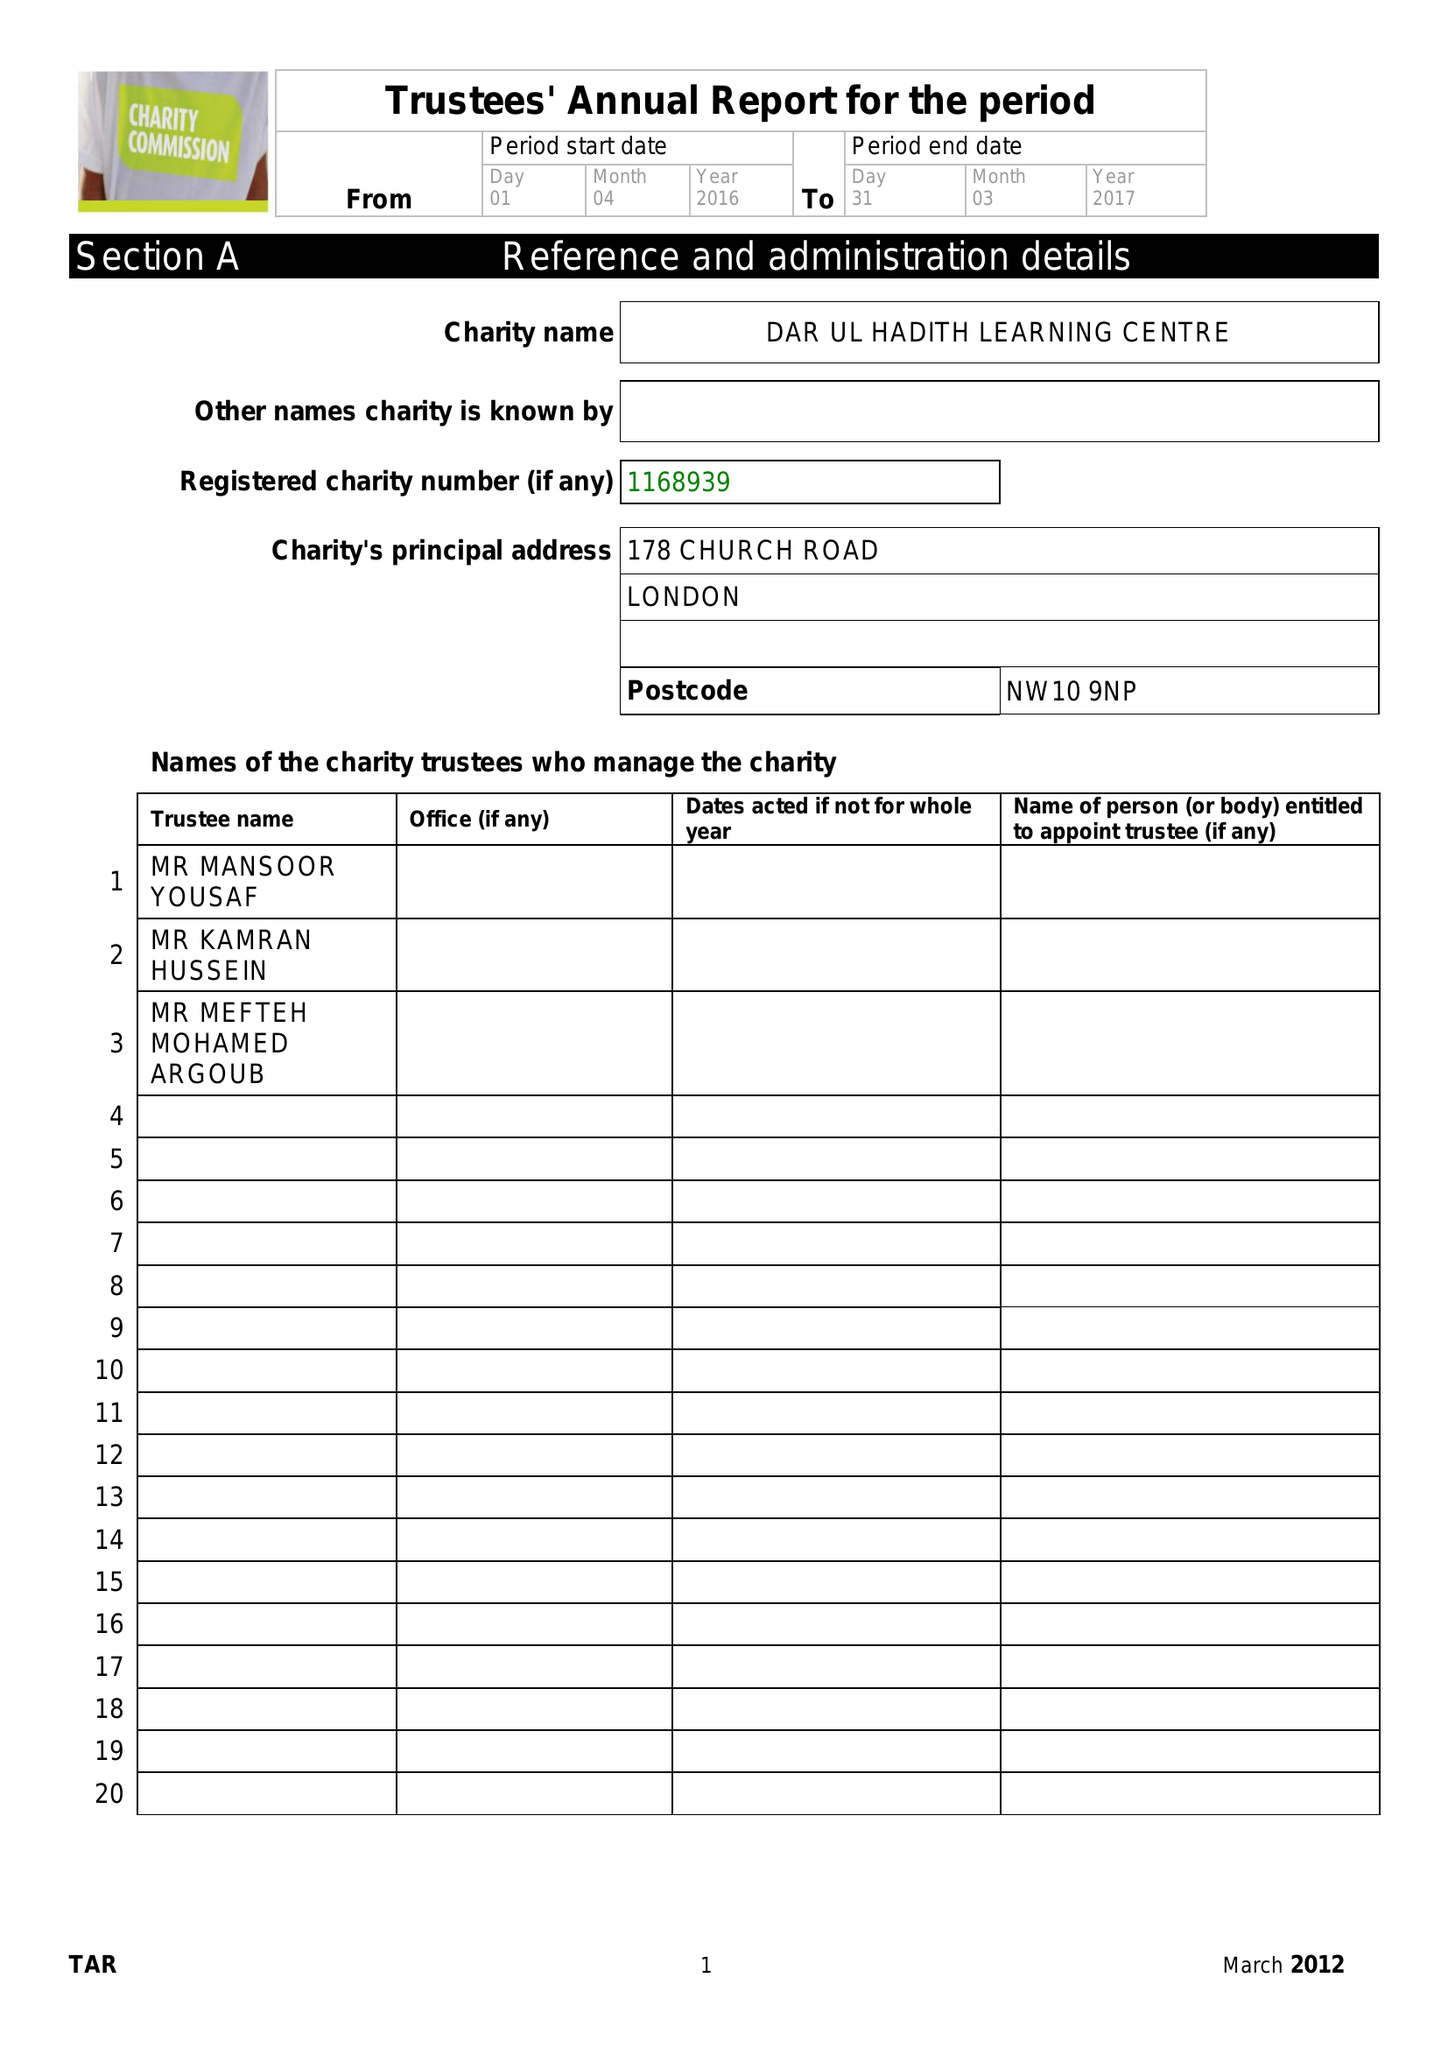What is the value for the address__street_line?
Answer the question using a single word or phrase. 178 CHURCH ROAD 